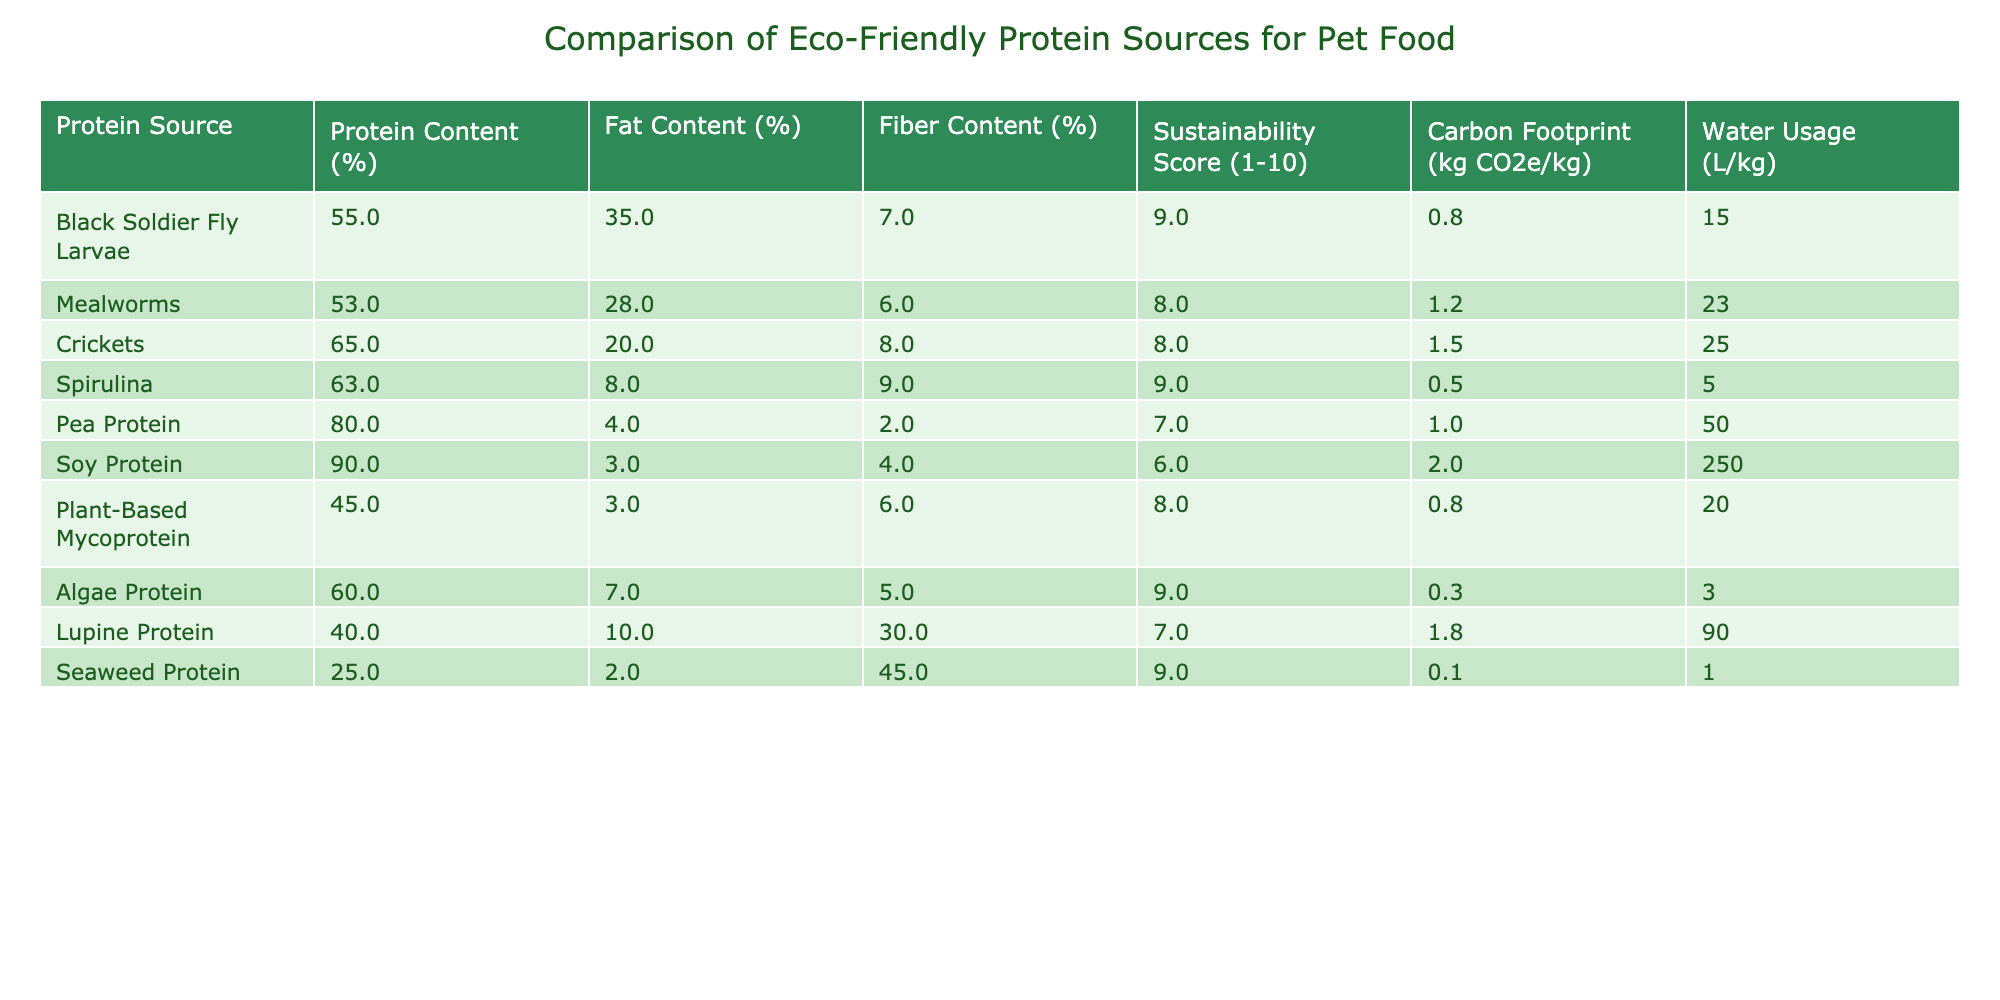What is the protein content of Pea Protein? The table lists Pea Protein with a protein content of 80%.
Answer: 80% Which protein source has the highest fat content? The table shows Crickets with the highest fat content at 20%.
Answer: Crickets Is the carbon footprint of Seaweed Protein lower than that of Black Soldier Fly Larvae? The carbon footprint of Seaweed Protein is 0.1 kg CO2e/kg, which is lower than Black Soldier Fly Larvae at 0.8 kg CO2e/kg.
Answer: Yes What is the average water usage of the protein sources listed? Adding the water usage values (15 + 23 + 25 + 5 + 50 + 250 + 20 + 3 + 90 + 1) gives 488 liters. Dividing by the number of sources (10) results in an average of 48.8 L/kg.
Answer: 48.8 L/kg Which protein source has the highest sustainability score? Black Soldier Fly Larvae, Spirulina, and Seaweed Protein all have a sustainability score of 9, which is the highest.
Answer: Black Soldier Fly Larvae, Spirulina, and Seaweed Protein Does any protein source have a fat content greater than 30%? Black Soldier Fly Larvae has a fat content of 35%, which is greater than 30%.
Answer: Yes What is the difference in protein content between Soy Protein and Crickets? Soy Protein has a protein content of 90%, while Crickets have 65%. The difference is 90 - 65 = 25%.
Answer: 25% How many protein sources have a sustainability score of 8 or higher? The sources with a score of 8 or higher are Black Soldier Fly Larvae, Spirulina, Crickets, Mealworms, Plant-Based Mycoprotein, and Seaweed Protein. This totals 6 sources.
Answer: 6 What is the carbon footprint of Algae Protein? The table lists Algae Protein with a carbon footprint of 0.3 kg CO2e/kg.
Answer: 0.3 kg CO2e/kg Which protein source has the lowest fiber content? The table indicates Seaweed Protein has the lowest fiber content at 45%.
Answer: Seaweed Protein 